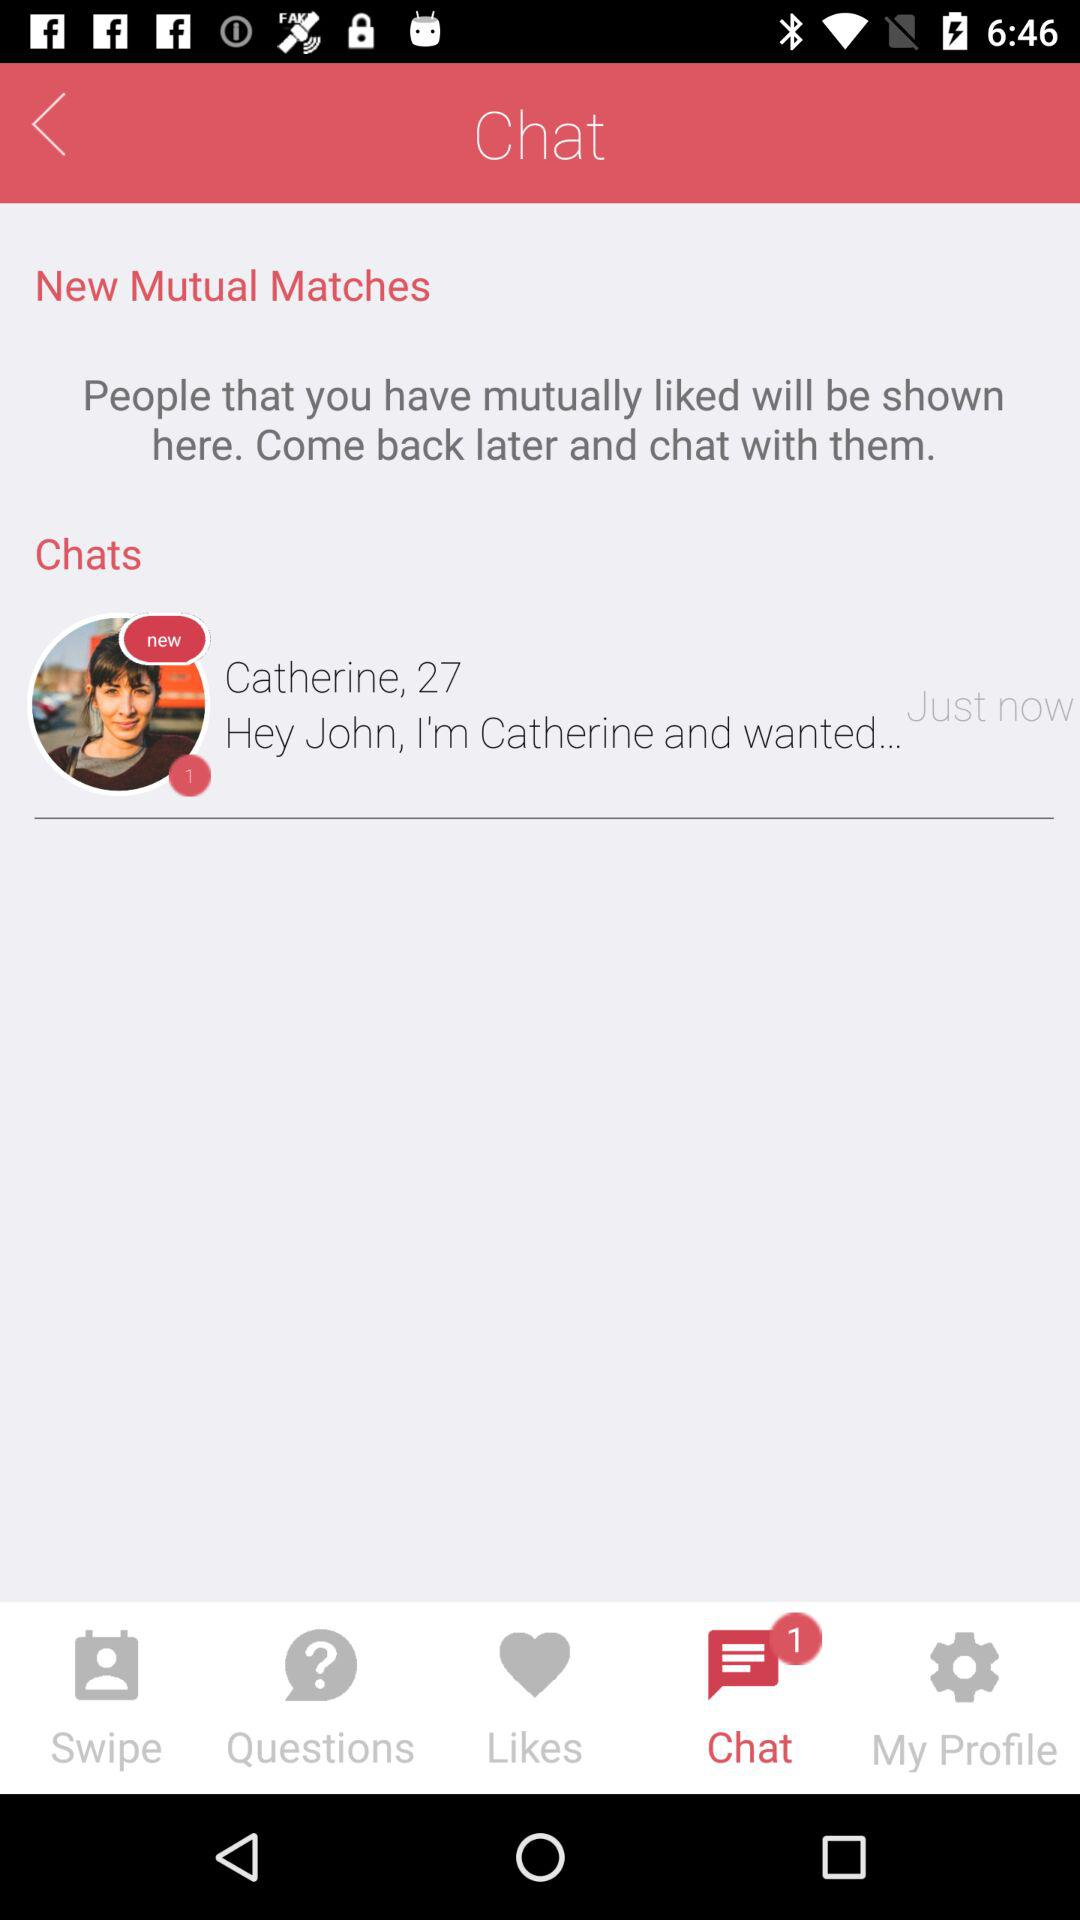When did Catherine send a message? Catherine sent a message "Just now". 